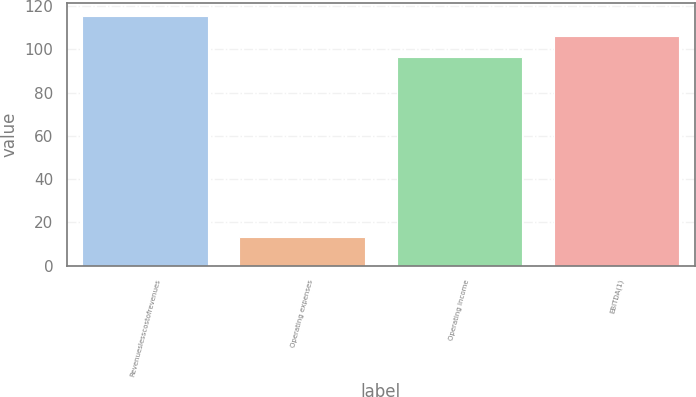<chart> <loc_0><loc_0><loc_500><loc_500><bar_chart><fcel>Revenueslesscostofrevenues<fcel>Operating expenses<fcel>Operating income<fcel>EBITDA(1)<nl><fcel>115.68<fcel>13<fcel>96.4<fcel>106.04<nl></chart> 